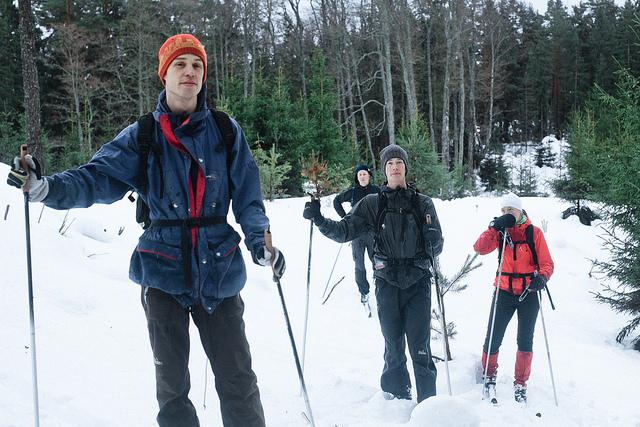What are the people doing?
Quick response, please. Skiing. Do the people look tired?
Keep it brief. Yes. How many people are wearing hats?
Write a very short answer. 4. 